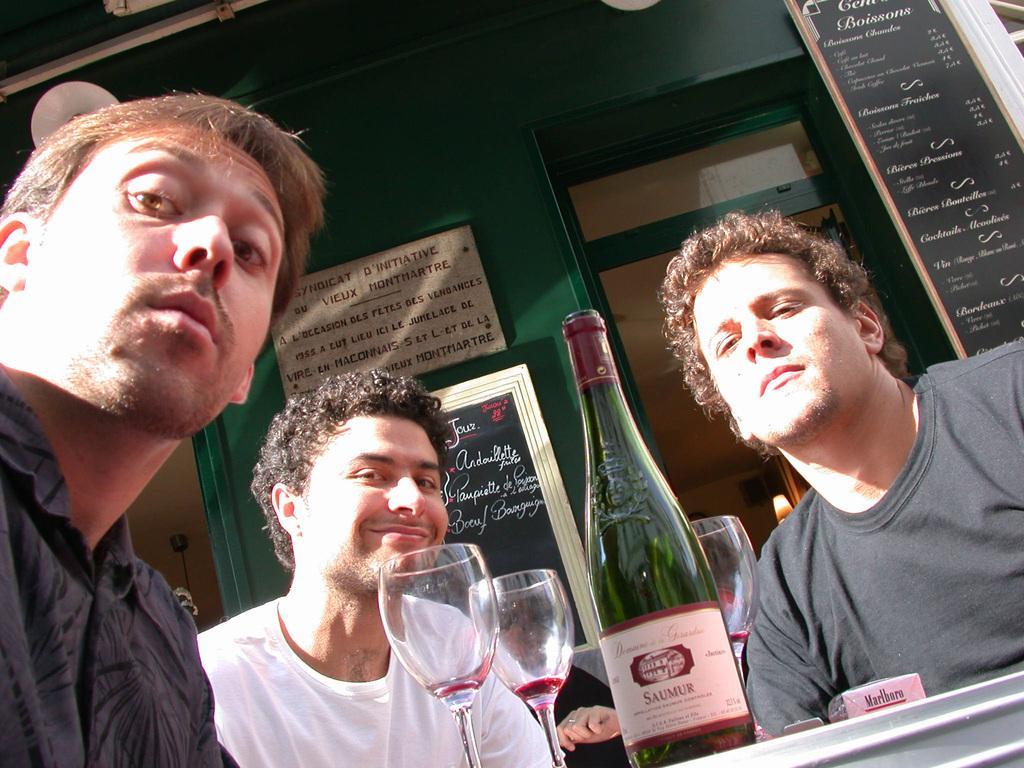In one or two sentences, can you explain what this image depicts? In the picture there are three men and and the person who is sitting in the middle smiling and there is also a table in front of them there is a wine bottle and three wine glasses and there is also a Cigar box. 